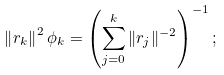<formula> <loc_0><loc_0><loc_500><loc_500>\left \| r _ { k } \right \| ^ { 2 } \phi _ { k } = \left ( \sum _ { j = 0 } ^ { k } \| r _ { j } \| ^ { - 2 } \right ) ^ { - 1 } ;</formula> 